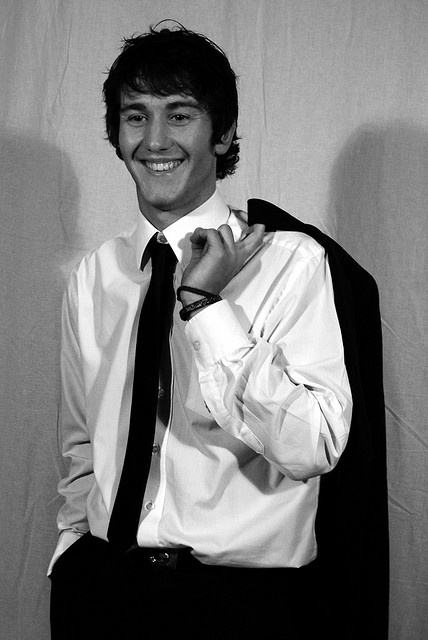Describe the objects in this image and their specific colors. I can see people in gray, black, lightgray, and darkgray tones and tie in gray, black, darkgray, and lightgray tones in this image. 